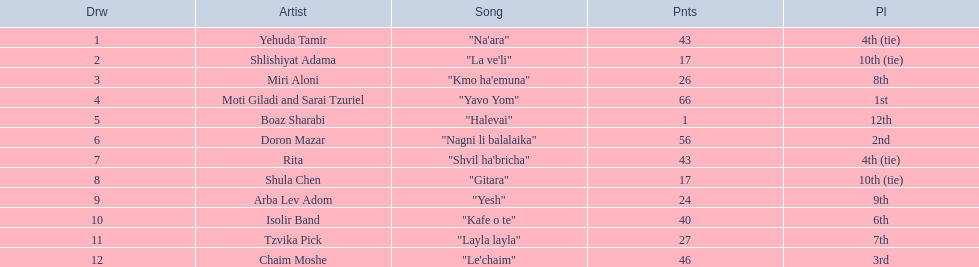What are the points in the competition? 43, 17, 26, 66, 1, 56, 43, 17, 24, 40, 27, 46. What is the lowest points? 1. What artist received these points? Boaz Sharabi. 